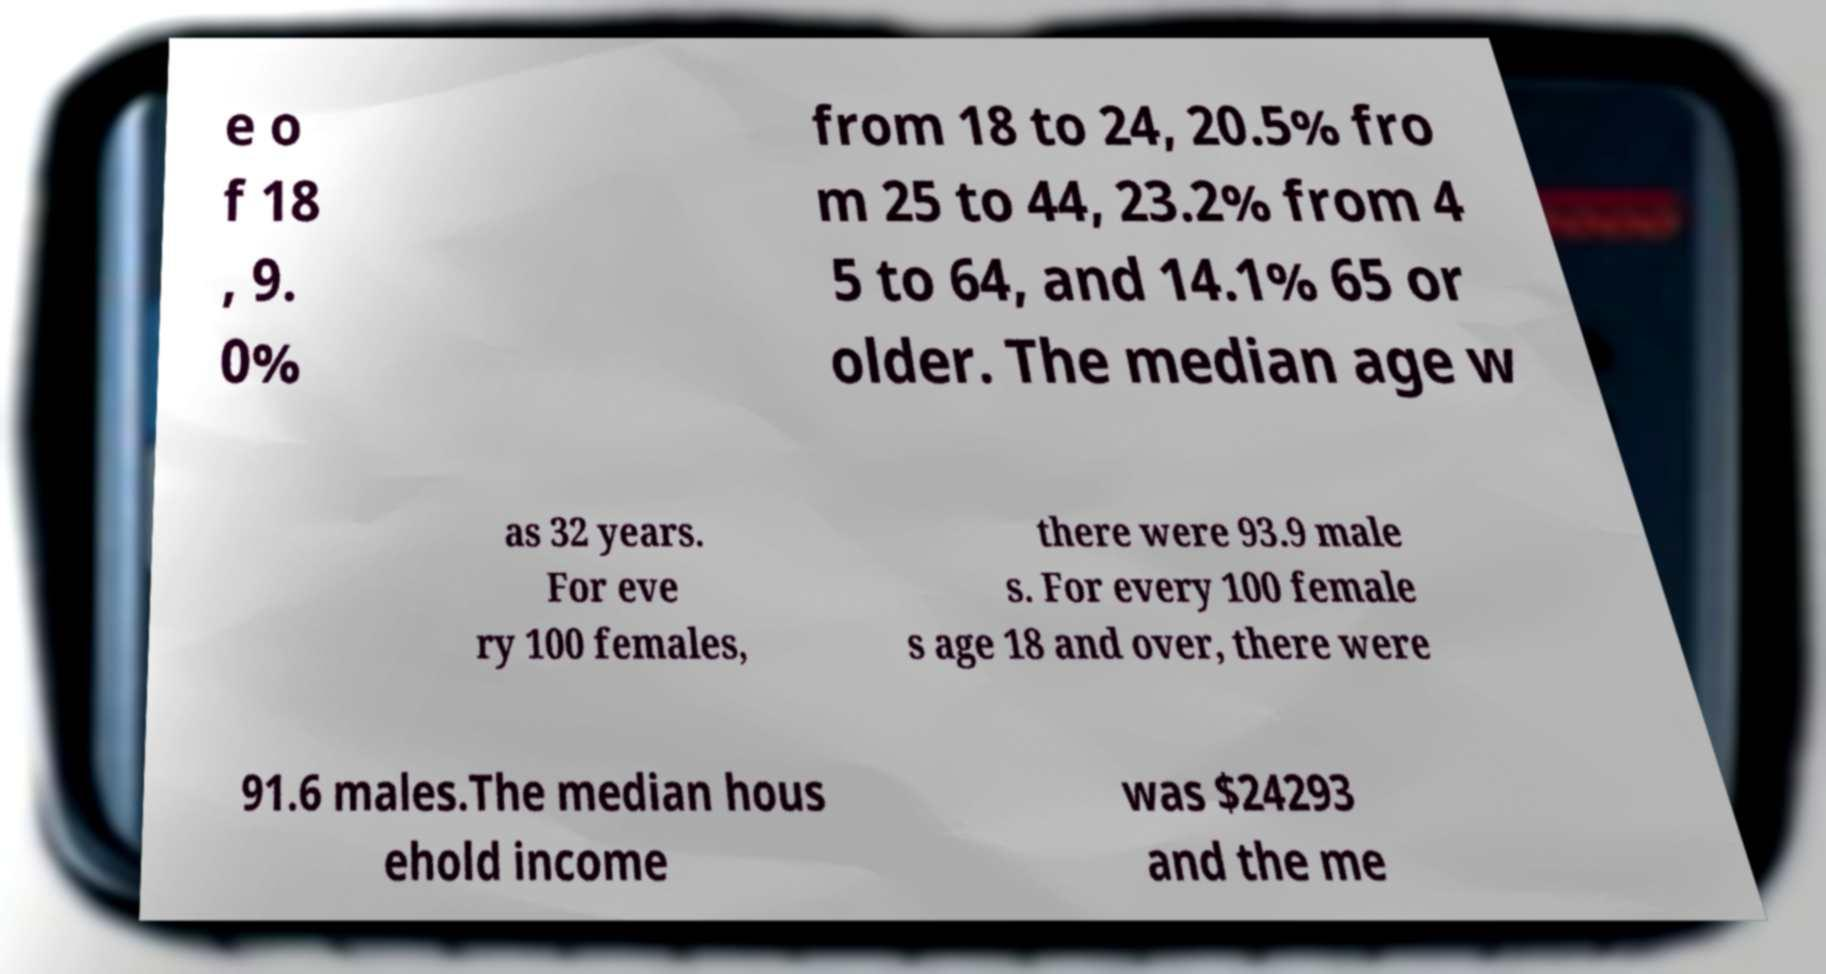Can you read and provide the text displayed in the image?This photo seems to have some interesting text. Can you extract and type it out for me? e o f 18 , 9. 0% from 18 to 24, 20.5% fro m 25 to 44, 23.2% from 4 5 to 64, and 14.1% 65 or older. The median age w as 32 years. For eve ry 100 females, there were 93.9 male s. For every 100 female s age 18 and over, there were 91.6 males.The median hous ehold income was $24293 and the me 